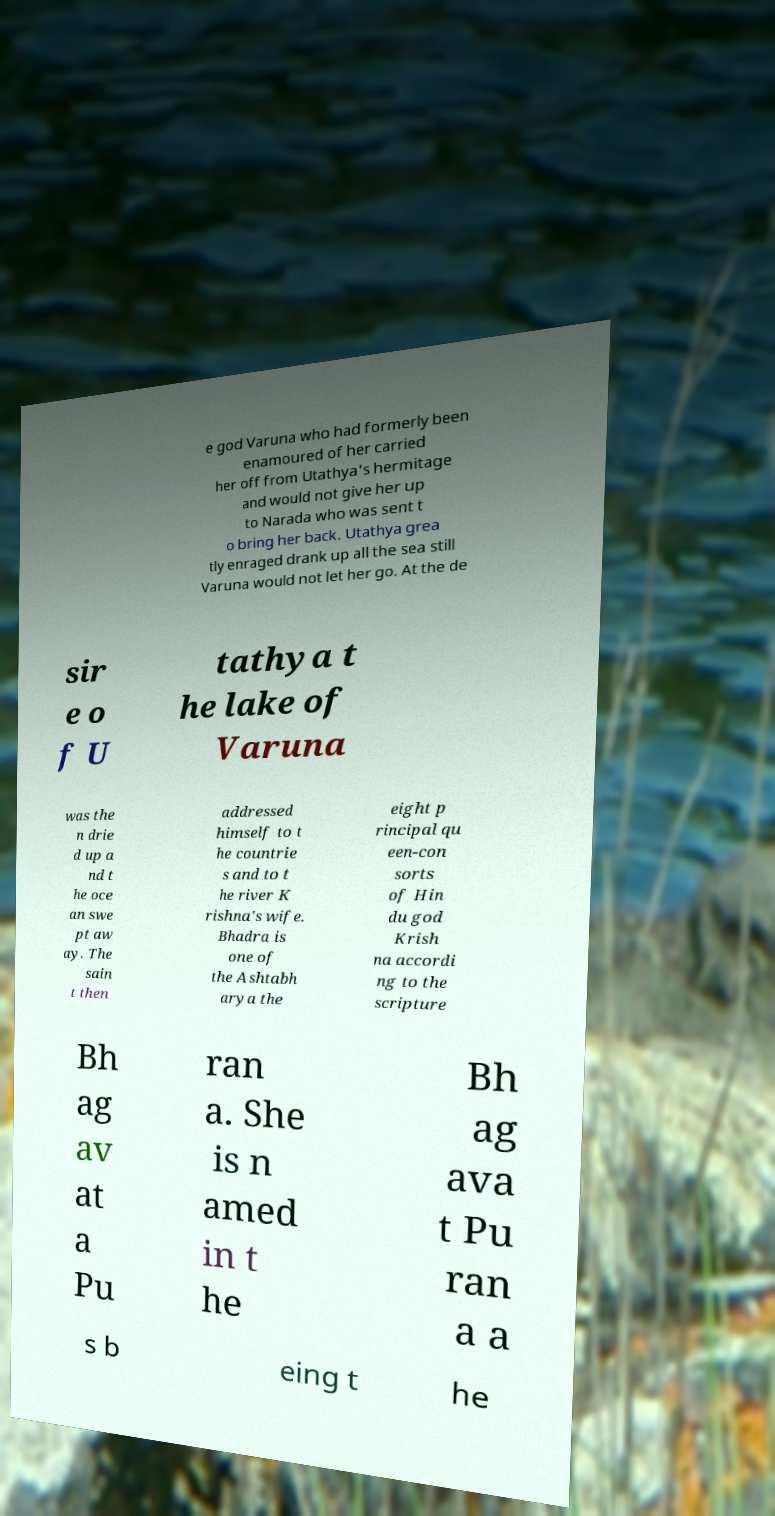For documentation purposes, I need the text within this image transcribed. Could you provide that? e god Varuna who had formerly been enamoured of her carried her off from Utathya's hermitage and would not give her up to Narada who was sent t o bring her back. Utathya grea tly enraged drank up all the sea still Varuna would not let her go. At the de sir e o f U tathya t he lake of Varuna was the n drie d up a nd t he oce an swe pt aw ay. The sain t then addressed himself to t he countrie s and to t he river K rishna's wife. Bhadra is one of the Ashtabh arya the eight p rincipal qu een-con sorts of Hin du god Krish na accordi ng to the scripture Bh ag av at a Pu ran a. She is n amed in t he Bh ag ava t Pu ran a a s b eing t he 